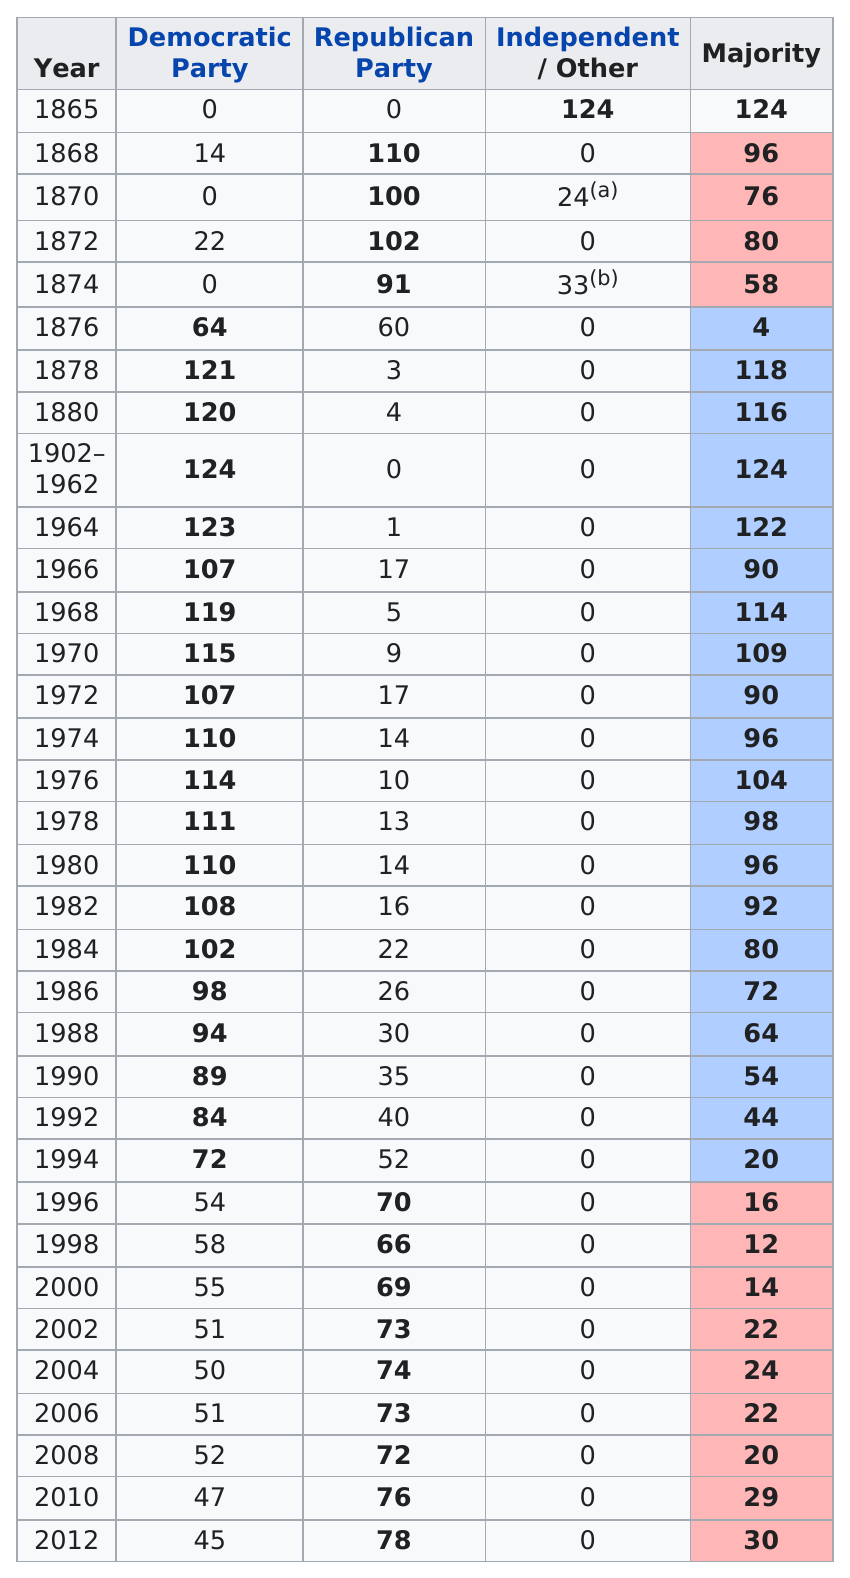Mention a couple of crucial points in this snapshot. In what years did the independent or other party have majority control in the South Carolina House of Representatives, specifically in 1865? The South Carolina House of Representatives composed of only Independents and no Democrats or Republicans for 1 year. During the years of 1868 and 1872, the Republican Party had more than 100 representatives in the South Carolina House of Representatives. In the years 1902 to 1962, the Democratic Party had the most representatives elected. Four consecutive Republican victories were achieved between 1865 and 1874. 